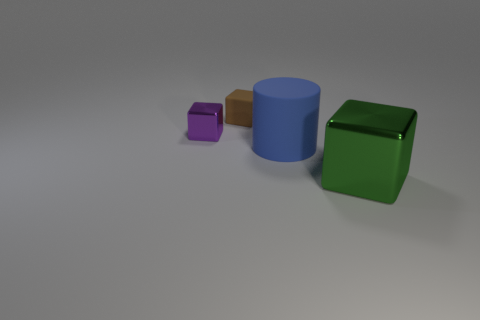How many objects are green blocks that are in front of the purple block or tiny cyan shiny blocks?
Keep it short and to the point. 1. There is a tiny object that is behind the metallic thing that is left of the metal thing that is in front of the small metallic object; what is its material?
Your answer should be very brief. Rubber. Are there more shiny things right of the green shiny thing than metallic blocks that are on the right side of the blue thing?
Your answer should be compact. No. What number of cubes are brown matte things or big rubber things?
Give a very brief answer. 1. There is a metal object that is behind the metallic thing to the right of the blue cylinder; what number of cubes are to the right of it?
Provide a short and direct response. 2. Is the number of large blue rubber cylinders greater than the number of tiny purple spheres?
Provide a succinct answer. Yes. Do the purple cube and the blue thing have the same size?
Your answer should be very brief. No. How many things are yellow cylinders or big things?
Your response must be concise. 2. What shape is the matte thing behind the metallic cube behind the object on the right side of the large blue rubber thing?
Your answer should be very brief. Cube. Does the cube right of the matte cylinder have the same material as the small object behind the tiny purple metallic block?
Your response must be concise. No. 